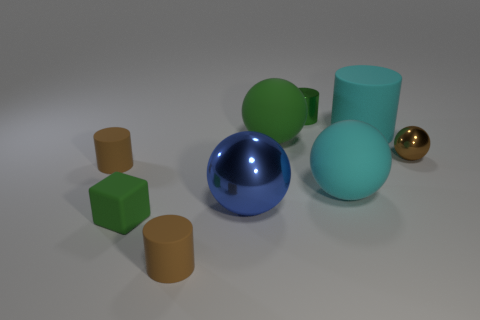Are there the same number of big shiny things to the right of the blue metal object and big cyan objects that are behind the big cyan rubber ball?
Provide a short and direct response. No. Is there any other thing that is made of the same material as the large cyan sphere?
Give a very brief answer. Yes. There is a green shiny thing; is its size the same as the green matte thing to the right of the big blue sphere?
Offer a terse response. No. There is a green thing that is left of the blue sphere that is on the left side of the small brown sphere; what is its material?
Provide a succinct answer. Rubber. Is the number of small brown metallic objects to the left of the small green metal cylinder the same as the number of green shiny things?
Give a very brief answer. No. How big is the rubber object that is to the left of the large cyan rubber ball and behind the brown metallic object?
Offer a terse response. Large. What color is the rubber block that is to the left of the small brown rubber cylinder that is in front of the block?
Offer a very short reply. Green. How many red objects are tiny cylinders or metal things?
Keep it short and to the point. 0. There is a shiny object that is both on the left side of the tiny brown metallic sphere and in front of the big cyan cylinder; what color is it?
Give a very brief answer. Blue. What number of large things are either green cubes or cyan objects?
Keep it short and to the point. 2. 